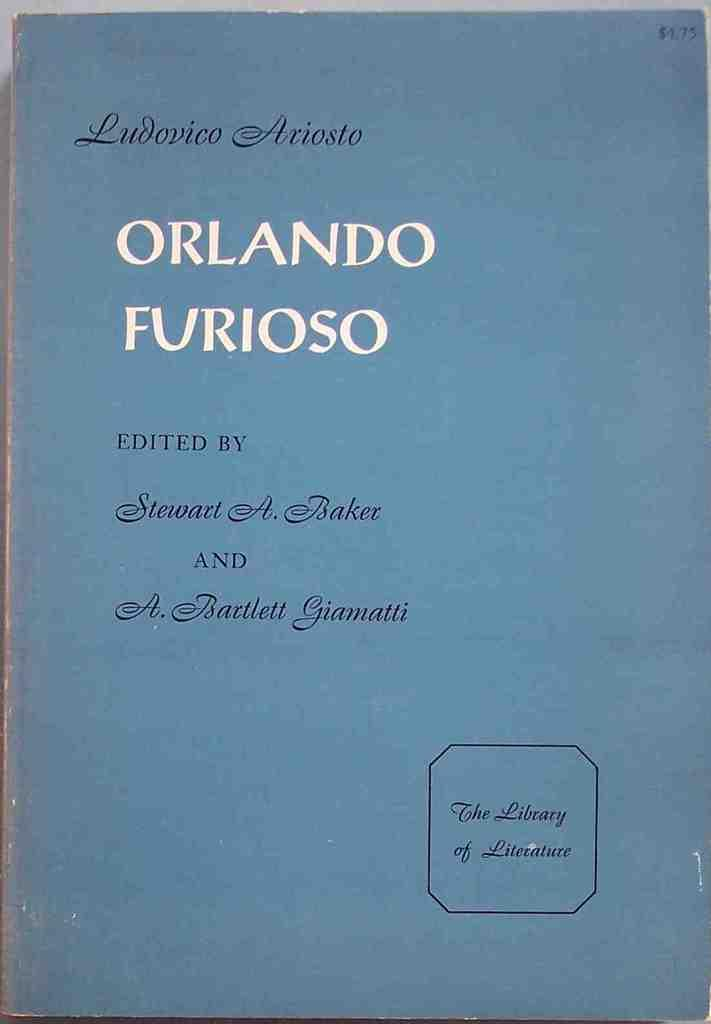<image>
Offer a succinct explanation of the picture presented. A blue book cover is titled Orlando Furioso. 